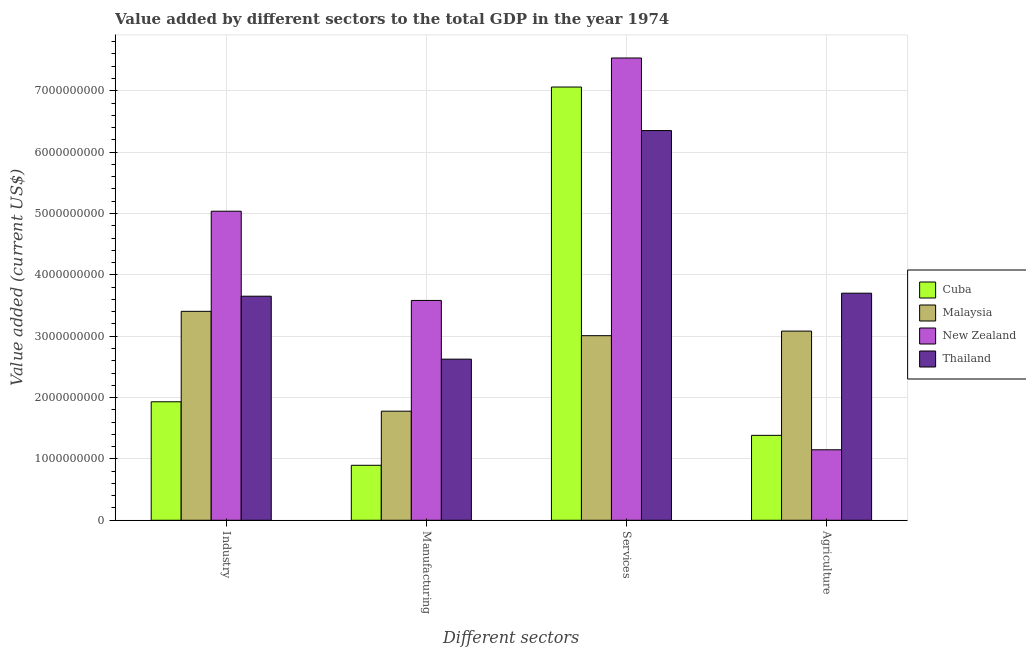Are the number of bars per tick equal to the number of legend labels?
Ensure brevity in your answer.  Yes. Are the number of bars on each tick of the X-axis equal?
Keep it short and to the point. Yes. What is the label of the 2nd group of bars from the left?
Offer a very short reply. Manufacturing. What is the value added by agricultural sector in Malaysia?
Give a very brief answer. 3.08e+09. Across all countries, what is the maximum value added by agricultural sector?
Give a very brief answer. 3.70e+09. Across all countries, what is the minimum value added by industrial sector?
Offer a terse response. 1.93e+09. In which country was the value added by industrial sector maximum?
Offer a terse response. New Zealand. In which country was the value added by services sector minimum?
Make the answer very short. Malaysia. What is the total value added by manufacturing sector in the graph?
Offer a very short reply. 8.88e+09. What is the difference between the value added by services sector in New Zealand and that in Thailand?
Provide a short and direct response. 1.18e+09. What is the difference between the value added by manufacturing sector in Cuba and the value added by services sector in Thailand?
Give a very brief answer. -5.45e+09. What is the average value added by manufacturing sector per country?
Provide a succinct answer. 2.22e+09. What is the difference between the value added by services sector and value added by industrial sector in Thailand?
Your answer should be very brief. 2.70e+09. What is the ratio of the value added by services sector in New Zealand to that in Thailand?
Your answer should be compact. 1.19. What is the difference between the highest and the second highest value added by manufacturing sector?
Offer a very short reply. 9.57e+08. What is the difference between the highest and the lowest value added by services sector?
Make the answer very short. 4.53e+09. Is the sum of the value added by manufacturing sector in Thailand and New Zealand greater than the maximum value added by services sector across all countries?
Provide a succinct answer. No. What does the 2nd bar from the left in Industry represents?
Your response must be concise. Malaysia. What does the 2nd bar from the right in Industry represents?
Your answer should be compact. New Zealand. Is it the case that in every country, the sum of the value added by industrial sector and value added by manufacturing sector is greater than the value added by services sector?
Your answer should be very brief. No. How many bars are there?
Your response must be concise. 16. Are all the bars in the graph horizontal?
Provide a succinct answer. No. What is the difference between two consecutive major ticks on the Y-axis?
Ensure brevity in your answer.  1.00e+09. Are the values on the major ticks of Y-axis written in scientific E-notation?
Give a very brief answer. No. How are the legend labels stacked?
Your answer should be compact. Vertical. What is the title of the graph?
Keep it short and to the point. Value added by different sectors to the total GDP in the year 1974. What is the label or title of the X-axis?
Keep it short and to the point. Different sectors. What is the label or title of the Y-axis?
Make the answer very short. Value added (current US$). What is the Value added (current US$) in Cuba in Industry?
Your response must be concise. 1.93e+09. What is the Value added (current US$) in Malaysia in Industry?
Keep it short and to the point. 3.40e+09. What is the Value added (current US$) of New Zealand in Industry?
Keep it short and to the point. 5.04e+09. What is the Value added (current US$) of Thailand in Industry?
Your answer should be very brief. 3.65e+09. What is the Value added (current US$) of Cuba in Manufacturing?
Your answer should be compact. 8.96e+08. What is the Value added (current US$) in Malaysia in Manufacturing?
Provide a succinct answer. 1.78e+09. What is the Value added (current US$) of New Zealand in Manufacturing?
Make the answer very short. 3.58e+09. What is the Value added (current US$) in Thailand in Manufacturing?
Provide a short and direct response. 2.63e+09. What is the Value added (current US$) of Cuba in Services?
Provide a succinct answer. 7.06e+09. What is the Value added (current US$) of Malaysia in Services?
Offer a terse response. 3.01e+09. What is the Value added (current US$) in New Zealand in Services?
Give a very brief answer. 7.53e+09. What is the Value added (current US$) of Thailand in Services?
Your response must be concise. 6.35e+09. What is the Value added (current US$) in Cuba in Agriculture?
Your answer should be compact. 1.38e+09. What is the Value added (current US$) of Malaysia in Agriculture?
Give a very brief answer. 3.08e+09. What is the Value added (current US$) of New Zealand in Agriculture?
Your answer should be compact. 1.15e+09. What is the Value added (current US$) in Thailand in Agriculture?
Provide a short and direct response. 3.70e+09. Across all Different sectors, what is the maximum Value added (current US$) of Cuba?
Your answer should be very brief. 7.06e+09. Across all Different sectors, what is the maximum Value added (current US$) of Malaysia?
Provide a succinct answer. 3.40e+09. Across all Different sectors, what is the maximum Value added (current US$) in New Zealand?
Provide a succinct answer. 7.53e+09. Across all Different sectors, what is the maximum Value added (current US$) of Thailand?
Your answer should be very brief. 6.35e+09. Across all Different sectors, what is the minimum Value added (current US$) of Cuba?
Make the answer very short. 8.96e+08. Across all Different sectors, what is the minimum Value added (current US$) in Malaysia?
Provide a short and direct response. 1.78e+09. Across all Different sectors, what is the minimum Value added (current US$) of New Zealand?
Give a very brief answer. 1.15e+09. Across all Different sectors, what is the minimum Value added (current US$) of Thailand?
Your answer should be very brief. 2.63e+09. What is the total Value added (current US$) of Cuba in the graph?
Make the answer very short. 1.13e+1. What is the total Value added (current US$) of Malaysia in the graph?
Ensure brevity in your answer.  1.13e+1. What is the total Value added (current US$) of New Zealand in the graph?
Ensure brevity in your answer.  1.73e+1. What is the total Value added (current US$) in Thailand in the graph?
Keep it short and to the point. 1.63e+1. What is the difference between the Value added (current US$) of Cuba in Industry and that in Manufacturing?
Provide a succinct answer. 1.04e+09. What is the difference between the Value added (current US$) in Malaysia in Industry and that in Manufacturing?
Give a very brief answer. 1.63e+09. What is the difference between the Value added (current US$) of New Zealand in Industry and that in Manufacturing?
Your answer should be very brief. 1.45e+09. What is the difference between the Value added (current US$) of Thailand in Industry and that in Manufacturing?
Your answer should be compact. 1.03e+09. What is the difference between the Value added (current US$) of Cuba in Industry and that in Services?
Ensure brevity in your answer.  -5.13e+09. What is the difference between the Value added (current US$) of Malaysia in Industry and that in Services?
Your response must be concise. 3.97e+08. What is the difference between the Value added (current US$) in New Zealand in Industry and that in Services?
Ensure brevity in your answer.  -2.50e+09. What is the difference between the Value added (current US$) of Thailand in Industry and that in Services?
Make the answer very short. -2.70e+09. What is the difference between the Value added (current US$) of Cuba in Industry and that in Agriculture?
Make the answer very short. 5.47e+08. What is the difference between the Value added (current US$) in Malaysia in Industry and that in Agriculture?
Your response must be concise. 3.22e+08. What is the difference between the Value added (current US$) in New Zealand in Industry and that in Agriculture?
Your answer should be very brief. 3.89e+09. What is the difference between the Value added (current US$) of Thailand in Industry and that in Agriculture?
Offer a very short reply. -4.91e+07. What is the difference between the Value added (current US$) in Cuba in Manufacturing and that in Services?
Keep it short and to the point. -6.16e+09. What is the difference between the Value added (current US$) in Malaysia in Manufacturing and that in Services?
Make the answer very short. -1.23e+09. What is the difference between the Value added (current US$) of New Zealand in Manufacturing and that in Services?
Make the answer very short. -3.95e+09. What is the difference between the Value added (current US$) of Thailand in Manufacturing and that in Services?
Your response must be concise. -3.73e+09. What is the difference between the Value added (current US$) of Cuba in Manufacturing and that in Agriculture?
Keep it short and to the point. -4.88e+08. What is the difference between the Value added (current US$) in Malaysia in Manufacturing and that in Agriculture?
Your answer should be very brief. -1.31e+09. What is the difference between the Value added (current US$) of New Zealand in Manufacturing and that in Agriculture?
Provide a short and direct response. 2.43e+09. What is the difference between the Value added (current US$) in Thailand in Manufacturing and that in Agriculture?
Offer a very short reply. -1.07e+09. What is the difference between the Value added (current US$) of Cuba in Services and that in Agriculture?
Your answer should be compact. 5.68e+09. What is the difference between the Value added (current US$) in Malaysia in Services and that in Agriculture?
Make the answer very short. -7.47e+07. What is the difference between the Value added (current US$) of New Zealand in Services and that in Agriculture?
Ensure brevity in your answer.  6.39e+09. What is the difference between the Value added (current US$) of Thailand in Services and that in Agriculture?
Provide a short and direct response. 2.65e+09. What is the difference between the Value added (current US$) of Cuba in Industry and the Value added (current US$) of Malaysia in Manufacturing?
Provide a succinct answer. 1.53e+08. What is the difference between the Value added (current US$) in Cuba in Industry and the Value added (current US$) in New Zealand in Manufacturing?
Make the answer very short. -1.65e+09. What is the difference between the Value added (current US$) of Cuba in Industry and the Value added (current US$) of Thailand in Manufacturing?
Give a very brief answer. -6.95e+08. What is the difference between the Value added (current US$) in Malaysia in Industry and the Value added (current US$) in New Zealand in Manufacturing?
Your answer should be very brief. -1.77e+08. What is the difference between the Value added (current US$) in Malaysia in Industry and the Value added (current US$) in Thailand in Manufacturing?
Provide a short and direct response. 7.79e+08. What is the difference between the Value added (current US$) of New Zealand in Industry and the Value added (current US$) of Thailand in Manufacturing?
Provide a short and direct response. 2.41e+09. What is the difference between the Value added (current US$) in Cuba in Industry and the Value added (current US$) in Malaysia in Services?
Make the answer very short. -1.08e+09. What is the difference between the Value added (current US$) in Cuba in Industry and the Value added (current US$) in New Zealand in Services?
Provide a succinct answer. -5.60e+09. What is the difference between the Value added (current US$) of Cuba in Industry and the Value added (current US$) of Thailand in Services?
Your response must be concise. -4.42e+09. What is the difference between the Value added (current US$) of Malaysia in Industry and the Value added (current US$) of New Zealand in Services?
Provide a short and direct response. -4.13e+09. What is the difference between the Value added (current US$) of Malaysia in Industry and the Value added (current US$) of Thailand in Services?
Your response must be concise. -2.95e+09. What is the difference between the Value added (current US$) of New Zealand in Industry and the Value added (current US$) of Thailand in Services?
Your response must be concise. -1.31e+09. What is the difference between the Value added (current US$) of Cuba in Industry and the Value added (current US$) of Malaysia in Agriculture?
Provide a succinct answer. -1.15e+09. What is the difference between the Value added (current US$) in Cuba in Industry and the Value added (current US$) in New Zealand in Agriculture?
Provide a short and direct response. 7.82e+08. What is the difference between the Value added (current US$) in Cuba in Industry and the Value added (current US$) in Thailand in Agriculture?
Provide a succinct answer. -1.77e+09. What is the difference between the Value added (current US$) of Malaysia in Industry and the Value added (current US$) of New Zealand in Agriculture?
Keep it short and to the point. 2.26e+09. What is the difference between the Value added (current US$) of Malaysia in Industry and the Value added (current US$) of Thailand in Agriculture?
Provide a succinct answer. -2.96e+08. What is the difference between the Value added (current US$) of New Zealand in Industry and the Value added (current US$) of Thailand in Agriculture?
Keep it short and to the point. 1.34e+09. What is the difference between the Value added (current US$) of Cuba in Manufacturing and the Value added (current US$) of Malaysia in Services?
Ensure brevity in your answer.  -2.11e+09. What is the difference between the Value added (current US$) in Cuba in Manufacturing and the Value added (current US$) in New Zealand in Services?
Your response must be concise. -6.64e+09. What is the difference between the Value added (current US$) of Cuba in Manufacturing and the Value added (current US$) of Thailand in Services?
Ensure brevity in your answer.  -5.45e+09. What is the difference between the Value added (current US$) in Malaysia in Manufacturing and the Value added (current US$) in New Zealand in Services?
Your response must be concise. -5.76e+09. What is the difference between the Value added (current US$) in Malaysia in Manufacturing and the Value added (current US$) in Thailand in Services?
Provide a succinct answer. -4.57e+09. What is the difference between the Value added (current US$) of New Zealand in Manufacturing and the Value added (current US$) of Thailand in Services?
Keep it short and to the point. -2.77e+09. What is the difference between the Value added (current US$) of Cuba in Manufacturing and the Value added (current US$) of Malaysia in Agriculture?
Offer a terse response. -2.19e+09. What is the difference between the Value added (current US$) of Cuba in Manufacturing and the Value added (current US$) of New Zealand in Agriculture?
Offer a very short reply. -2.53e+08. What is the difference between the Value added (current US$) of Cuba in Manufacturing and the Value added (current US$) of Thailand in Agriculture?
Give a very brief answer. -2.80e+09. What is the difference between the Value added (current US$) in Malaysia in Manufacturing and the Value added (current US$) in New Zealand in Agriculture?
Your answer should be very brief. 6.29e+08. What is the difference between the Value added (current US$) of Malaysia in Manufacturing and the Value added (current US$) of Thailand in Agriculture?
Offer a very short reply. -1.92e+09. What is the difference between the Value added (current US$) of New Zealand in Manufacturing and the Value added (current US$) of Thailand in Agriculture?
Give a very brief answer. -1.18e+08. What is the difference between the Value added (current US$) in Cuba in Services and the Value added (current US$) in Malaysia in Agriculture?
Make the answer very short. 3.98e+09. What is the difference between the Value added (current US$) in Cuba in Services and the Value added (current US$) in New Zealand in Agriculture?
Offer a terse response. 5.91e+09. What is the difference between the Value added (current US$) in Cuba in Services and the Value added (current US$) in Thailand in Agriculture?
Make the answer very short. 3.36e+09. What is the difference between the Value added (current US$) of Malaysia in Services and the Value added (current US$) of New Zealand in Agriculture?
Offer a very short reply. 1.86e+09. What is the difference between the Value added (current US$) of Malaysia in Services and the Value added (current US$) of Thailand in Agriculture?
Ensure brevity in your answer.  -6.92e+08. What is the difference between the Value added (current US$) of New Zealand in Services and the Value added (current US$) of Thailand in Agriculture?
Offer a terse response. 3.83e+09. What is the average Value added (current US$) of Cuba per Different sectors?
Provide a short and direct response. 2.82e+09. What is the average Value added (current US$) of Malaysia per Different sectors?
Your answer should be compact. 2.82e+09. What is the average Value added (current US$) of New Zealand per Different sectors?
Offer a terse response. 4.33e+09. What is the average Value added (current US$) of Thailand per Different sectors?
Your answer should be compact. 4.08e+09. What is the difference between the Value added (current US$) in Cuba and Value added (current US$) in Malaysia in Industry?
Provide a short and direct response. -1.47e+09. What is the difference between the Value added (current US$) of Cuba and Value added (current US$) of New Zealand in Industry?
Make the answer very short. -3.11e+09. What is the difference between the Value added (current US$) of Cuba and Value added (current US$) of Thailand in Industry?
Ensure brevity in your answer.  -1.72e+09. What is the difference between the Value added (current US$) in Malaysia and Value added (current US$) in New Zealand in Industry?
Provide a short and direct response. -1.63e+09. What is the difference between the Value added (current US$) in Malaysia and Value added (current US$) in Thailand in Industry?
Provide a succinct answer. -2.47e+08. What is the difference between the Value added (current US$) in New Zealand and Value added (current US$) in Thailand in Industry?
Keep it short and to the point. 1.39e+09. What is the difference between the Value added (current US$) of Cuba and Value added (current US$) of Malaysia in Manufacturing?
Your answer should be very brief. -8.82e+08. What is the difference between the Value added (current US$) in Cuba and Value added (current US$) in New Zealand in Manufacturing?
Your answer should be very brief. -2.69e+09. What is the difference between the Value added (current US$) of Cuba and Value added (current US$) of Thailand in Manufacturing?
Keep it short and to the point. -1.73e+09. What is the difference between the Value added (current US$) in Malaysia and Value added (current US$) in New Zealand in Manufacturing?
Provide a short and direct response. -1.80e+09. What is the difference between the Value added (current US$) of Malaysia and Value added (current US$) of Thailand in Manufacturing?
Make the answer very short. -8.48e+08. What is the difference between the Value added (current US$) of New Zealand and Value added (current US$) of Thailand in Manufacturing?
Make the answer very short. 9.57e+08. What is the difference between the Value added (current US$) of Cuba and Value added (current US$) of Malaysia in Services?
Give a very brief answer. 4.05e+09. What is the difference between the Value added (current US$) in Cuba and Value added (current US$) in New Zealand in Services?
Offer a terse response. -4.74e+08. What is the difference between the Value added (current US$) of Cuba and Value added (current US$) of Thailand in Services?
Keep it short and to the point. 7.09e+08. What is the difference between the Value added (current US$) in Malaysia and Value added (current US$) in New Zealand in Services?
Your response must be concise. -4.53e+09. What is the difference between the Value added (current US$) of Malaysia and Value added (current US$) of Thailand in Services?
Provide a short and direct response. -3.34e+09. What is the difference between the Value added (current US$) in New Zealand and Value added (current US$) in Thailand in Services?
Your answer should be compact. 1.18e+09. What is the difference between the Value added (current US$) of Cuba and Value added (current US$) of Malaysia in Agriculture?
Your answer should be compact. -1.70e+09. What is the difference between the Value added (current US$) of Cuba and Value added (current US$) of New Zealand in Agriculture?
Offer a very short reply. 2.35e+08. What is the difference between the Value added (current US$) in Cuba and Value added (current US$) in Thailand in Agriculture?
Give a very brief answer. -2.32e+09. What is the difference between the Value added (current US$) in Malaysia and Value added (current US$) in New Zealand in Agriculture?
Ensure brevity in your answer.  1.93e+09. What is the difference between the Value added (current US$) of Malaysia and Value added (current US$) of Thailand in Agriculture?
Provide a succinct answer. -6.18e+08. What is the difference between the Value added (current US$) of New Zealand and Value added (current US$) of Thailand in Agriculture?
Keep it short and to the point. -2.55e+09. What is the ratio of the Value added (current US$) in Cuba in Industry to that in Manufacturing?
Offer a terse response. 2.16. What is the ratio of the Value added (current US$) of Malaysia in Industry to that in Manufacturing?
Your answer should be very brief. 1.92. What is the ratio of the Value added (current US$) of New Zealand in Industry to that in Manufacturing?
Provide a succinct answer. 1.41. What is the ratio of the Value added (current US$) in Thailand in Industry to that in Manufacturing?
Offer a very short reply. 1.39. What is the ratio of the Value added (current US$) in Cuba in Industry to that in Services?
Give a very brief answer. 0.27. What is the ratio of the Value added (current US$) in Malaysia in Industry to that in Services?
Your answer should be compact. 1.13. What is the ratio of the Value added (current US$) of New Zealand in Industry to that in Services?
Make the answer very short. 0.67. What is the ratio of the Value added (current US$) in Thailand in Industry to that in Services?
Provide a short and direct response. 0.57. What is the ratio of the Value added (current US$) in Cuba in Industry to that in Agriculture?
Your answer should be compact. 1.4. What is the ratio of the Value added (current US$) in Malaysia in Industry to that in Agriculture?
Your answer should be compact. 1.1. What is the ratio of the Value added (current US$) in New Zealand in Industry to that in Agriculture?
Your answer should be very brief. 4.38. What is the ratio of the Value added (current US$) of Thailand in Industry to that in Agriculture?
Give a very brief answer. 0.99. What is the ratio of the Value added (current US$) of Cuba in Manufacturing to that in Services?
Your answer should be compact. 0.13. What is the ratio of the Value added (current US$) in Malaysia in Manufacturing to that in Services?
Offer a terse response. 0.59. What is the ratio of the Value added (current US$) of New Zealand in Manufacturing to that in Services?
Offer a very short reply. 0.48. What is the ratio of the Value added (current US$) of Thailand in Manufacturing to that in Services?
Provide a succinct answer. 0.41. What is the ratio of the Value added (current US$) of Cuba in Manufacturing to that in Agriculture?
Provide a succinct answer. 0.65. What is the ratio of the Value added (current US$) of Malaysia in Manufacturing to that in Agriculture?
Give a very brief answer. 0.58. What is the ratio of the Value added (current US$) in New Zealand in Manufacturing to that in Agriculture?
Ensure brevity in your answer.  3.12. What is the ratio of the Value added (current US$) in Thailand in Manufacturing to that in Agriculture?
Provide a short and direct response. 0.71. What is the ratio of the Value added (current US$) of Cuba in Services to that in Agriculture?
Ensure brevity in your answer.  5.1. What is the ratio of the Value added (current US$) in Malaysia in Services to that in Agriculture?
Keep it short and to the point. 0.98. What is the ratio of the Value added (current US$) in New Zealand in Services to that in Agriculture?
Your answer should be very brief. 6.56. What is the ratio of the Value added (current US$) of Thailand in Services to that in Agriculture?
Make the answer very short. 1.72. What is the difference between the highest and the second highest Value added (current US$) in Cuba?
Your response must be concise. 5.13e+09. What is the difference between the highest and the second highest Value added (current US$) of Malaysia?
Make the answer very short. 3.22e+08. What is the difference between the highest and the second highest Value added (current US$) in New Zealand?
Provide a succinct answer. 2.50e+09. What is the difference between the highest and the second highest Value added (current US$) in Thailand?
Make the answer very short. 2.65e+09. What is the difference between the highest and the lowest Value added (current US$) in Cuba?
Provide a short and direct response. 6.16e+09. What is the difference between the highest and the lowest Value added (current US$) of Malaysia?
Keep it short and to the point. 1.63e+09. What is the difference between the highest and the lowest Value added (current US$) of New Zealand?
Your answer should be compact. 6.39e+09. What is the difference between the highest and the lowest Value added (current US$) in Thailand?
Provide a short and direct response. 3.73e+09. 